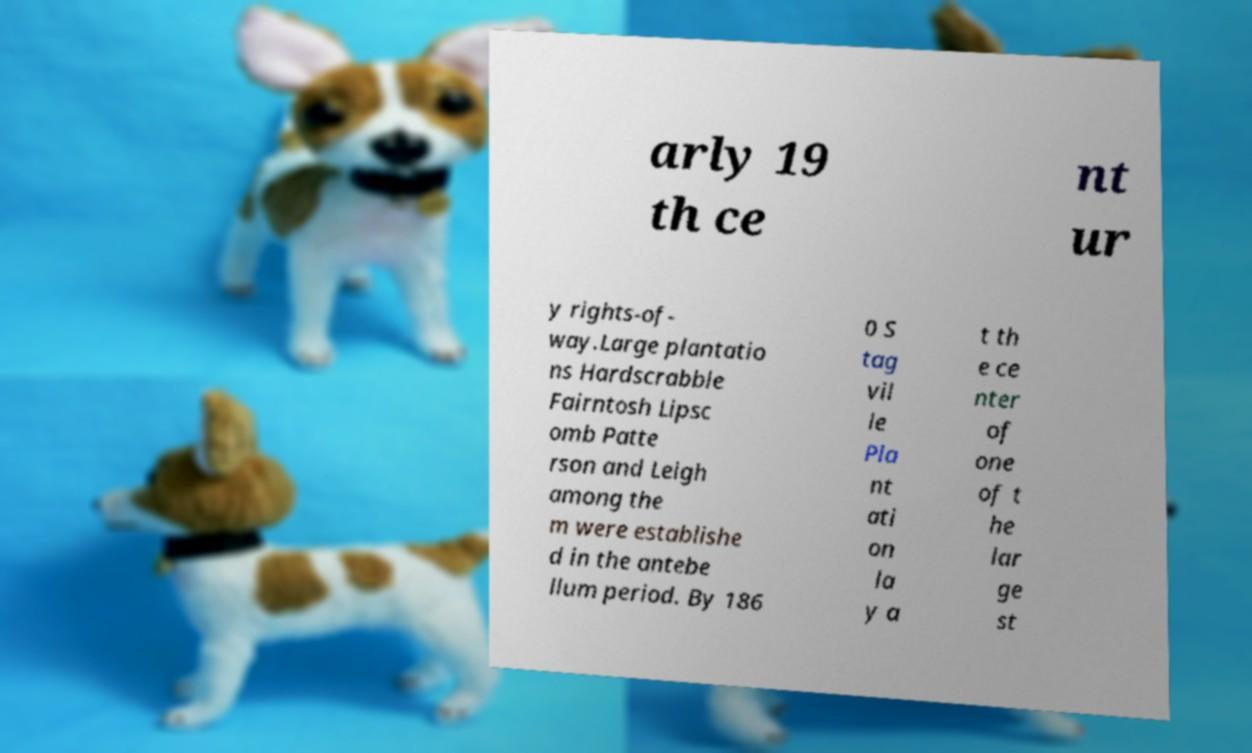Can you accurately transcribe the text from the provided image for me? arly 19 th ce nt ur y rights-of- way.Large plantatio ns Hardscrabble Fairntosh Lipsc omb Patte rson and Leigh among the m were establishe d in the antebe llum period. By 186 0 S tag vil le Pla nt ati on la y a t th e ce nter of one of t he lar ge st 